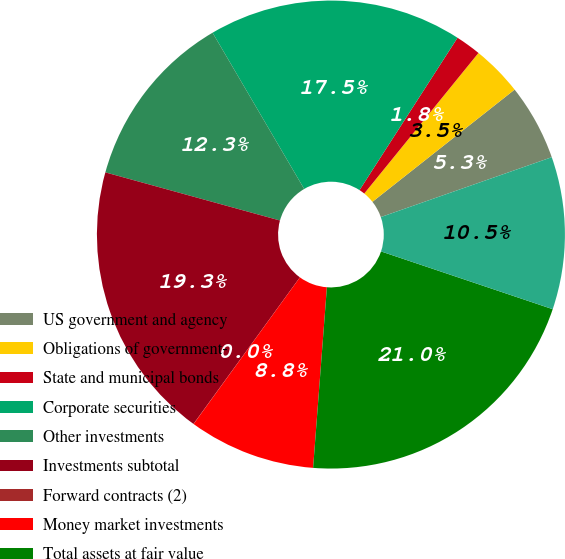Convert chart to OTSL. <chart><loc_0><loc_0><loc_500><loc_500><pie_chart><fcel>US government and agency<fcel>Obligations of government-<fcel>State and municipal bonds<fcel>Corporate securities<fcel>Other investments<fcel>Investments subtotal<fcel>Forward contracts (2)<fcel>Money market investments<fcel>Total assets at fair value<fcel>Liabilities related to the<nl><fcel>5.27%<fcel>3.51%<fcel>1.76%<fcel>17.54%<fcel>12.28%<fcel>19.29%<fcel>0.01%<fcel>8.77%<fcel>21.05%<fcel>10.53%<nl></chart> 